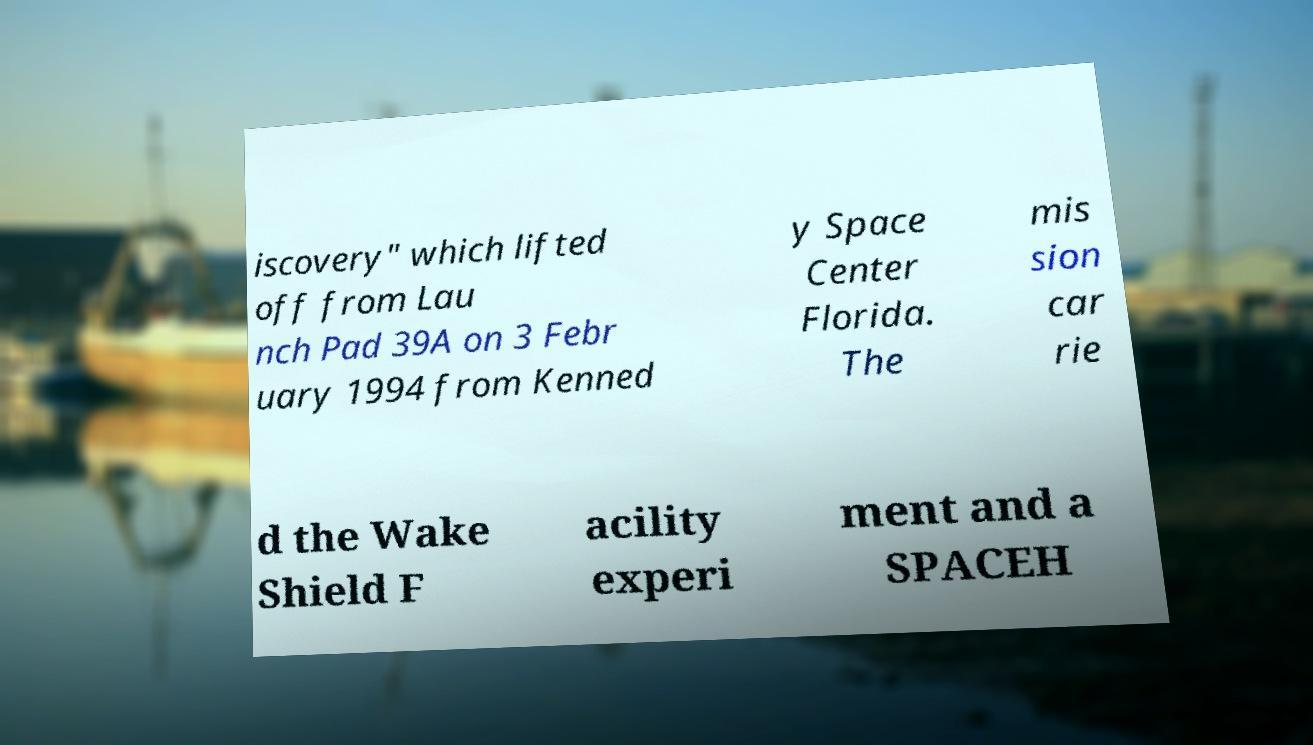Can you read and provide the text displayed in the image?This photo seems to have some interesting text. Can you extract and type it out for me? iscovery" which lifted off from Lau nch Pad 39A on 3 Febr uary 1994 from Kenned y Space Center Florida. The mis sion car rie d the Wake Shield F acility experi ment and a SPACEH 